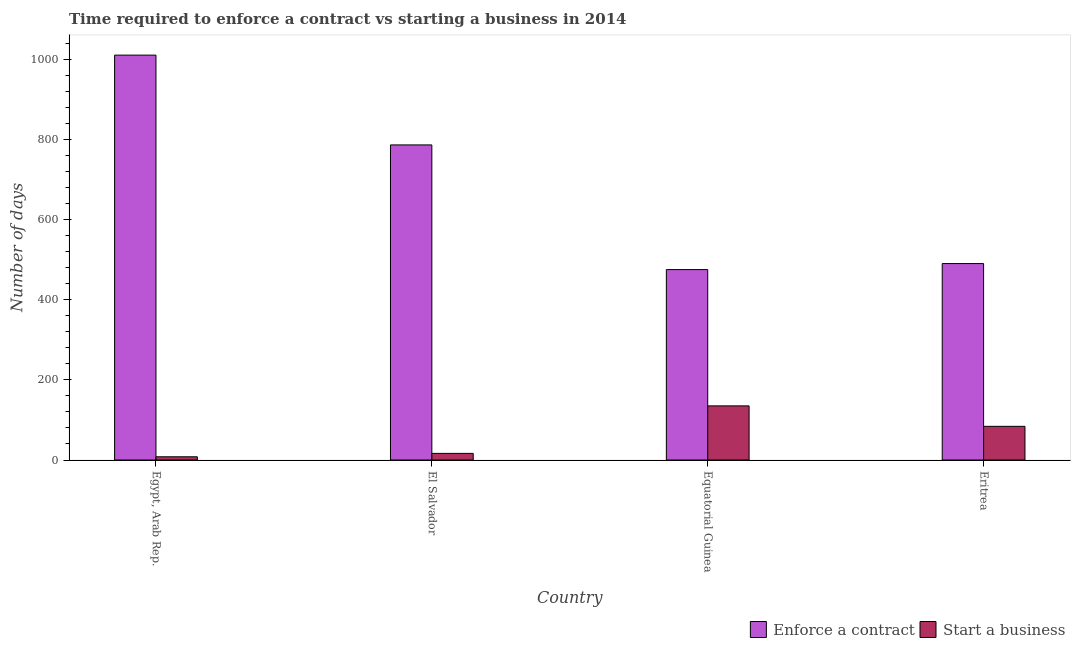How many different coloured bars are there?
Ensure brevity in your answer.  2. How many groups of bars are there?
Your answer should be very brief. 4. How many bars are there on the 1st tick from the left?
Your answer should be very brief. 2. How many bars are there on the 4th tick from the right?
Offer a very short reply. 2. What is the label of the 2nd group of bars from the left?
Your answer should be compact. El Salvador. In how many cases, is the number of bars for a given country not equal to the number of legend labels?
Offer a very short reply. 0. What is the number of days to enforece a contract in Equatorial Guinea?
Ensure brevity in your answer.  475. Across all countries, what is the maximum number of days to enforece a contract?
Give a very brief answer. 1010. In which country was the number of days to start a business maximum?
Ensure brevity in your answer.  Equatorial Guinea. In which country was the number of days to start a business minimum?
Keep it short and to the point. Egypt, Arab Rep. What is the total number of days to start a business in the graph?
Ensure brevity in your answer.  243.5. What is the difference between the number of days to enforece a contract in El Salvador and that in Eritrea?
Give a very brief answer. 296. What is the difference between the number of days to enforece a contract in Equatorial Guinea and the number of days to start a business in Egypt, Arab Rep.?
Ensure brevity in your answer.  467. What is the average number of days to start a business per country?
Provide a short and direct response. 60.88. What is the difference between the number of days to enforece a contract and number of days to start a business in El Salvador?
Your answer should be compact. 769.5. What is the ratio of the number of days to start a business in Egypt, Arab Rep. to that in Eritrea?
Give a very brief answer. 0.1. Is the number of days to start a business in El Salvador less than that in Eritrea?
Your answer should be very brief. Yes. Is the difference between the number of days to start a business in Egypt, Arab Rep. and Eritrea greater than the difference between the number of days to enforece a contract in Egypt, Arab Rep. and Eritrea?
Make the answer very short. No. What is the difference between the highest and the second highest number of days to enforece a contract?
Provide a short and direct response. 224. What is the difference between the highest and the lowest number of days to enforece a contract?
Make the answer very short. 535. Is the sum of the number of days to enforece a contract in Egypt, Arab Rep. and El Salvador greater than the maximum number of days to start a business across all countries?
Your answer should be very brief. Yes. What does the 2nd bar from the left in Eritrea represents?
Make the answer very short. Start a business. What does the 2nd bar from the right in Equatorial Guinea represents?
Offer a very short reply. Enforce a contract. How many bars are there?
Provide a short and direct response. 8. Are all the bars in the graph horizontal?
Your response must be concise. No. What is the difference between two consecutive major ticks on the Y-axis?
Keep it short and to the point. 200. Does the graph contain any zero values?
Provide a short and direct response. No. What is the title of the graph?
Provide a short and direct response. Time required to enforce a contract vs starting a business in 2014. Does "Arms exports" appear as one of the legend labels in the graph?
Give a very brief answer. No. What is the label or title of the Y-axis?
Provide a succinct answer. Number of days. What is the Number of days in Enforce a contract in Egypt, Arab Rep.?
Keep it short and to the point. 1010. What is the Number of days of Start a business in Egypt, Arab Rep.?
Keep it short and to the point. 8. What is the Number of days of Enforce a contract in El Salvador?
Ensure brevity in your answer.  786. What is the Number of days of Start a business in El Salvador?
Keep it short and to the point. 16.5. What is the Number of days of Enforce a contract in Equatorial Guinea?
Offer a very short reply. 475. What is the Number of days of Start a business in Equatorial Guinea?
Your answer should be very brief. 135. What is the Number of days in Enforce a contract in Eritrea?
Make the answer very short. 490. What is the Number of days of Start a business in Eritrea?
Your answer should be compact. 84. Across all countries, what is the maximum Number of days of Enforce a contract?
Keep it short and to the point. 1010. Across all countries, what is the maximum Number of days in Start a business?
Provide a short and direct response. 135. Across all countries, what is the minimum Number of days in Enforce a contract?
Offer a very short reply. 475. Across all countries, what is the minimum Number of days in Start a business?
Offer a terse response. 8. What is the total Number of days of Enforce a contract in the graph?
Give a very brief answer. 2761. What is the total Number of days of Start a business in the graph?
Make the answer very short. 243.5. What is the difference between the Number of days in Enforce a contract in Egypt, Arab Rep. and that in El Salvador?
Your response must be concise. 224. What is the difference between the Number of days in Start a business in Egypt, Arab Rep. and that in El Salvador?
Ensure brevity in your answer.  -8.5. What is the difference between the Number of days of Enforce a contract in Egypt, Arab Rep. and that in Equatorial Guinea?
Offer a terse response. 535. What is the difference between the Number of days in Start a business in Egypt, Arab Rep. and that in Equatorial Guinea?
Offer a terse response. -127. What is the difference between the Number of days of Enforce a contract in Egypt, Arab Rep. and that in Eritrea?
Offer a terse response. 520. What is the difference between the Number of days in Start a business in Egypt, Arab Rep. and that in Eritrea?
Offer a very short reply. -76. What is the difference between the Number of days of Enforce a contract in El Salvador and that in Equatorial Guinea?
Your response must be concise. 311. What is the difference between the Number of days in Start a business in El Salvador and that in Equatorial Guinea?
Your answer should be compact. -118.5. What is the difference between the Number of days in Enforce a contract in El Salvador and that in Eritrea?
Your answer should be very brief. 296. What is the difference between the Number of days of Start a business in El Salvador and that in Eritrea?
Keep it short and to the point. -67.5. What is the difference between the Number of days of Start a business in Equatorial Guinea and that in Eritrea?
Your answer should be compact. 51. What is the difference between the Number of days of Enforce a contract in Egypt, Arab Rep. and the Number of days of Start a business in El Salvador?
Give a very brief answer. 993.5. What is the difference between the Number of days of Enforce a contract in Egypt, Arab Rep. and the Number of days of Start a business in Equatorial Guinea?
Ensure brevity in your answer.  875. What is the difference between the Number of days in Enforce a contract in Egypt, Arab Rep. and the Number of days in Start a business in Eritrea?
Your answer should be compact. 926. What is the difference between the Number of days of Enforce a contract in El Salvador and the Number of days of Start a business in Equatorial Guinea?
Ensure brevity in your answer.  651. What is the difference between the Number of days in Enforce a contract in El Salvador and the Number of days in Start a business in Eritrea?
Your response must be concise. 702. What is the difference between the Number of days of Enforce a contract in Equatorial Guinea and the Number of days of Start a business in Eritrea?
Your answer should be very brief. 391. What is the average Number of days of Enforce a contract per country?
Your answer should be very brief. 690.25. What is the average Number of days in Start a business per country?
Your answer should be compact. 60.88. What is the difference between the Number of days of Enforce a contract and Number of days of Start a business in Egypt, Arab Rep.?
Your response must be concise. 1002. What is the difference between the Number of days in Enforce a contract and Number of days in Start a business in El Salvador?
Keep it short and to the point. 769.5. What is the difference between the Number of days of Enforce a contract and Number of days of Start a business in Equatorial Guinea?
Your answer should be compact. 340. What is the difference between the Number of days of Enforce a contract and Number of days of Start a business in Eritrea?
Make the answer very short. 406. What is the ratio of the Number of days of Enforce a contract in Egypt, Arab Rep. to that in El Salvador?
Keep it short and to the point. 1.28. What is the ratio of the Number of days of Start a business in Egypt, Arab Rep. to that in El Salvador?
Provide a short and direct response. 0.48. What is the ratio of the Number of days in Enforce a contract in Egypt, Arab Rep. to that in Equatorial Guinea?
Provide a succinct answer. 2.13. What is the ratio of the Number of days of Start a business in Egypt, Arab Rep. to that in Equatorial Guinea?
Offer a terse response. 0.06. What is the ratio of the Number of days in Enforce a contract in Egypt, Arab Rep. to that in Eritrea?
Ensure brevity in your answer.  2.06. What is the ratio of the Number of days in Start a business in Egypt, Arab Rep. to that in Eritrea?
Offer a very short reply. 0.1. What is the ratio of the Number of days of Enforce a contract in El Salvador to that in Equatorial Guinea?
Offer a terse response. 1.65. What is the ratio of the Number of days in Start a business in El Salvador to that in Equatorial Guinea?
Provide a succinct answer. 0.12. What is the ratio of the Number of days of Enforce a contract in El Salvador to that in Eritrea?
Provide a succinct answer. 1.6. What is the ratio of the Number of days of Start a business in El Salvador to that in Eritrea?
Provide a succinct answer. 0.2. What is the ratio of the Number of days in Enforce a contract in Equatorial Guinea to that in Eritrea?
Your response must be concise. 0.97. What is the ratio of the Number of days in Start a business in Equatorial Guinea to that in Eritrea?
Your response must be concise. 1.61. What is the difference between the highest and the second highest Number of days of Enforce a contract?
Give a very brief answer. 224. What is the difference between the highest and the lowest Number of days of Enforce a contract?
Your answer should be very brief. 535. What is the difference between the highest and the lowest Number of days in Start a business?
Provide a succinct answer. 127. 